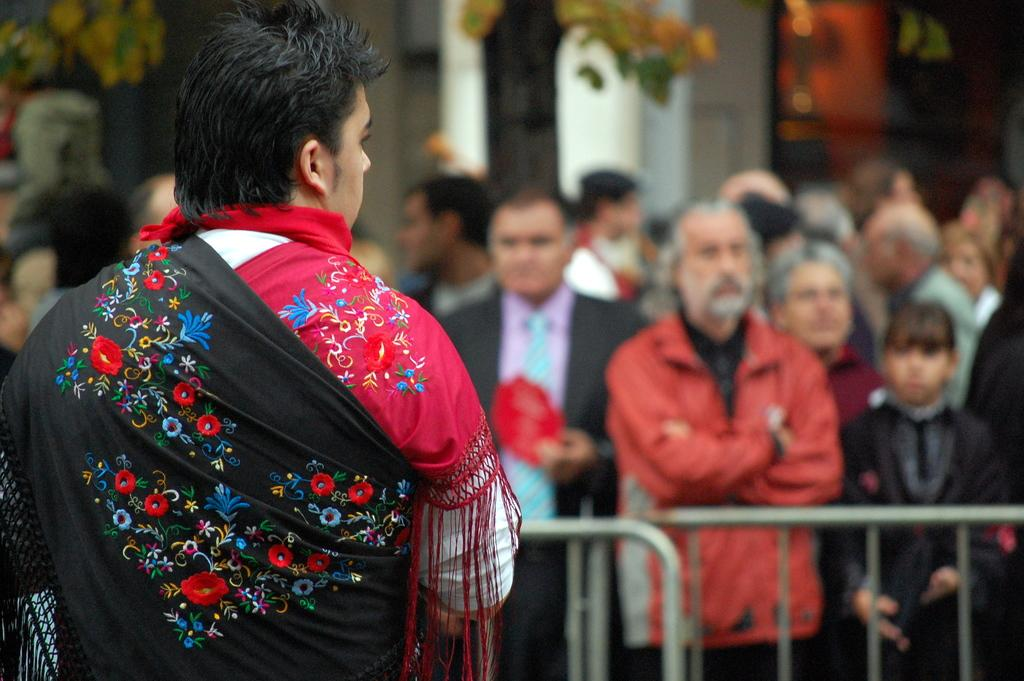What is the main subject of the image? There is a person in the image. What is happening around the person? There is a group of people standing in front of the person. What can be seen in the image besides the people? There is a fence and a tree in the image. What is visible in the background of the image? There are objects visible in the background, but they are blurry. Can you see any worms crawling on the person in the image? No, there are no worms visible in the image. What type of wound is visible on the person in the image? There is no wound visible on the person in the image. 